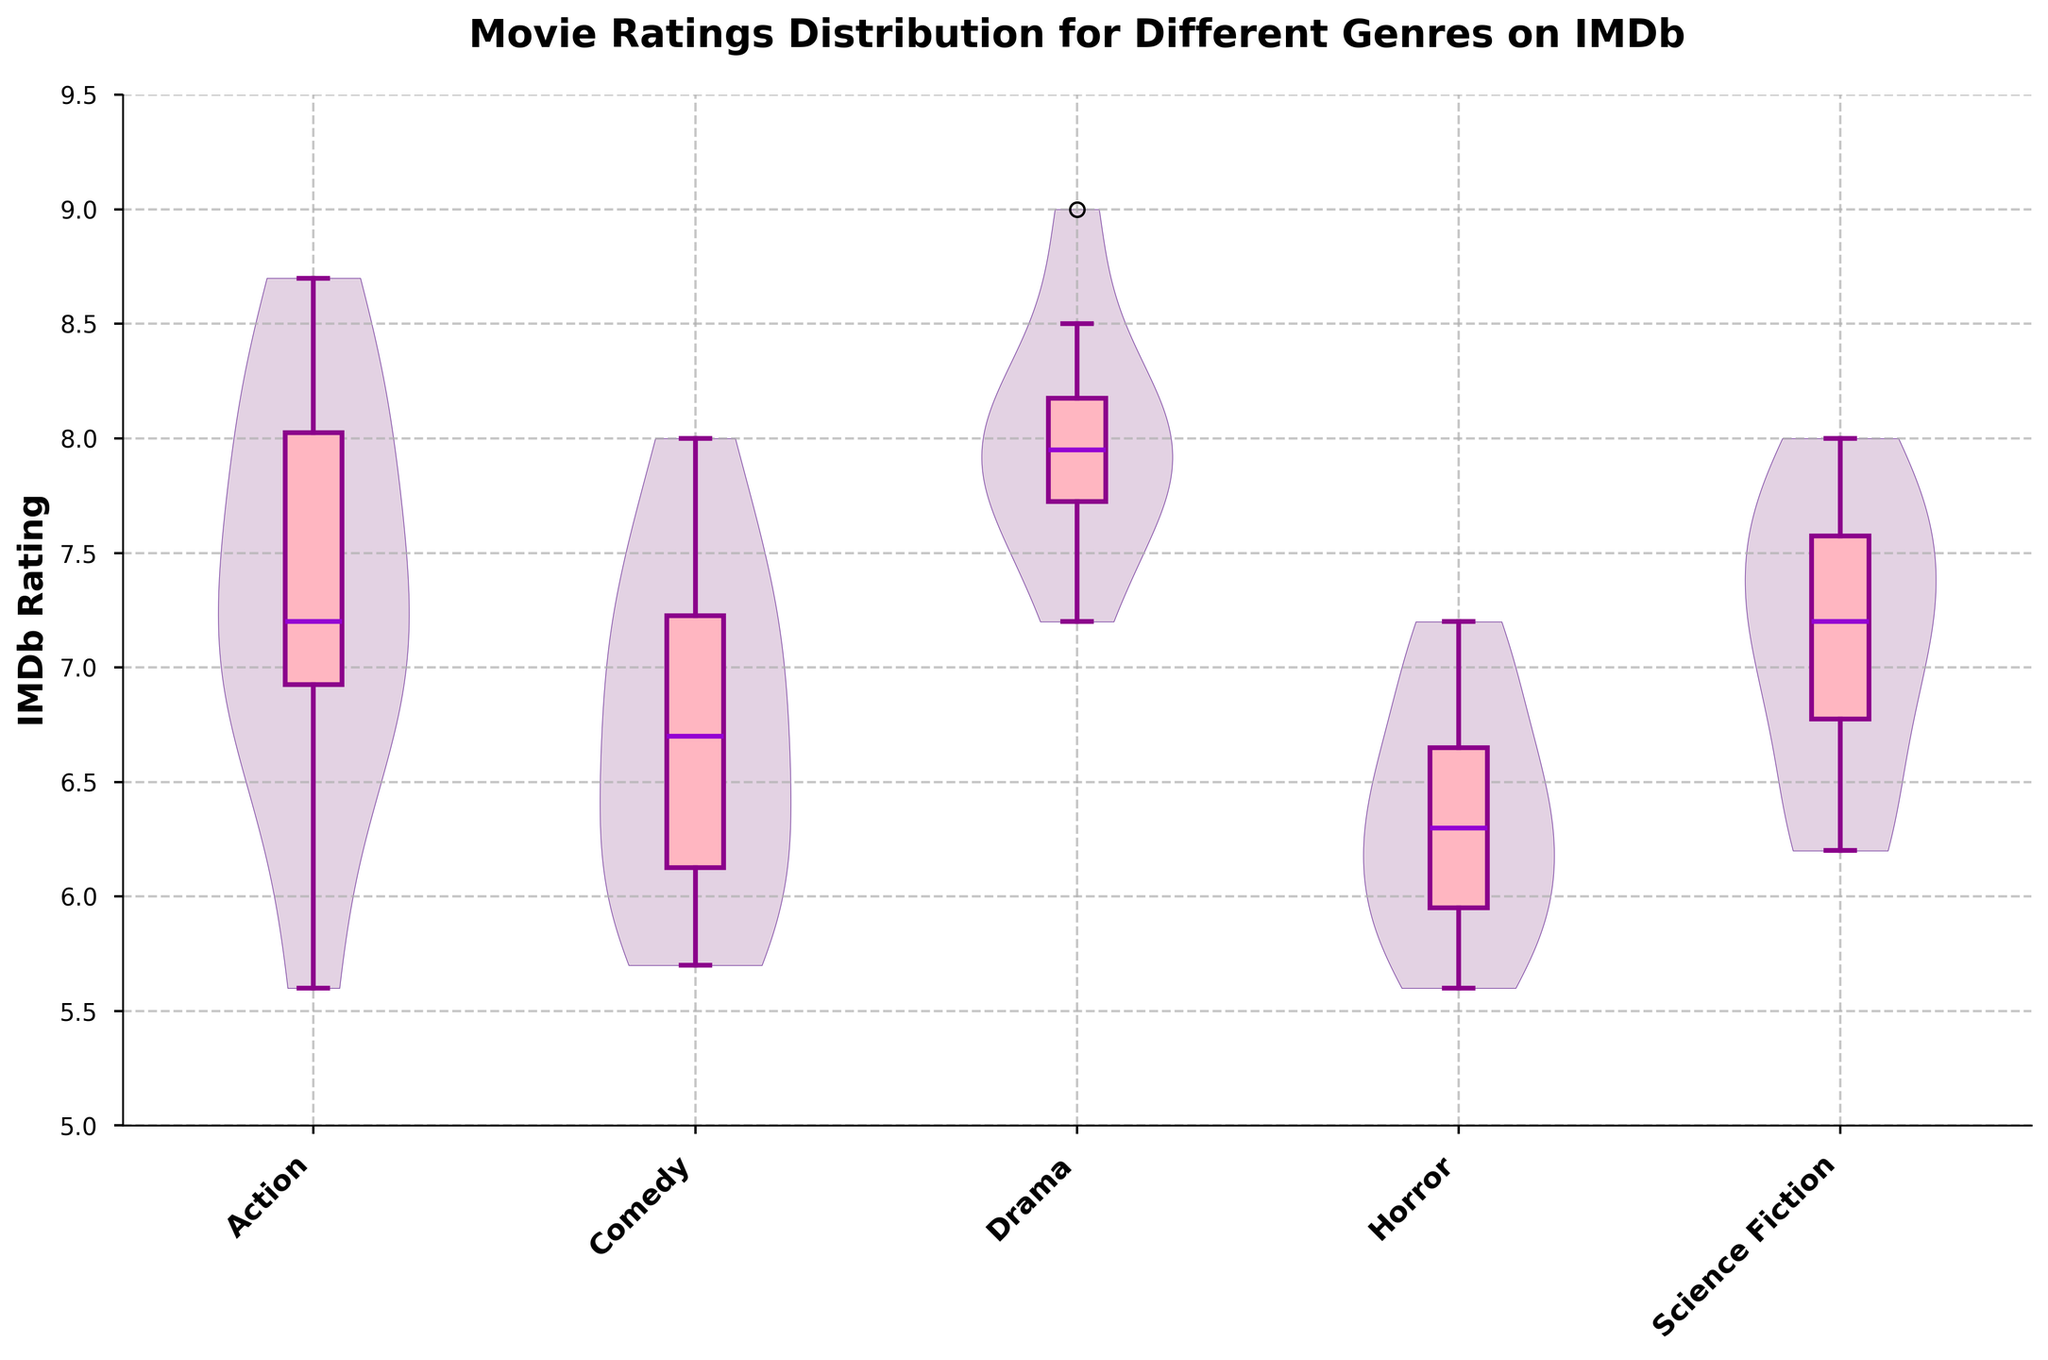What's the title of the violin chart with box plot overlay? The title of the violin chart with box plot overlay is found at the top of the figure and it states the main subject or focus of the plot. It reads "Movie Ratings Distribution for Different Genres on IMDb".
Answer: Movie Ratings Distribution for Different Genres on IMDb What are the ranges of IMDb ratings shown on the y-axis? The y-axis of the figure represents the IMDb ratings. The scale starts at 5 and goes up to 9.5. This range is indicated by the tick marks and numbers along the y-axis.
Answer: 5 to 9.5 Which genre has the highest median rating? The box plot overlay shows the median rating as a line inside each box. By comparing the medians for each genre, the drama genre has the highest median rating, which is slightly above 8.
Answer: Drama What is the median rating for the horror genre? To find the median rating, look for the line within the box plot for the horror genre. The line representing the median rating in horror is at 6.4.
Answer: 6.4 How does the distribution of ratings in the comedy genre compare to the action genre? By observing the widths and shapes of the violin plots, as well as the positions of the box plots, one can compare the distributions. The comedy genre has a wider spread, with more concentration around the median, whereas the action genre shows a somewhat narrower distribution.
Answer: Comedy is wider and more concentrated around the median, Action is narrower Which genre has the widest spread of ratings? The spread of ratings can be observed from the width of the violin plot. The comedy genre has the widest spread, indicating a broader variety of ratings.
Answer: Comedy What is the lowest rating observed for the action genre? The lowest rating in the action genre can be found at the bottom of the box plot's whisker for that genre, which dips down to approximately 5.6.
Answer: 5.6 Are the median ratings of the genres uniformly distributed? By examining the positions of the lines inside each genre's box plot, it is clear that the median ratings vary significantly across genres. They range from about 6.4 to slightly above 8, indicating a non-uniform distribution.
Answer: No By how much does the highest rating in the drama genre exceed the highest rating in the science fiction genre? The highest rating in the drama genre is 9, while the highest rating in the science fiction genre is 8. To find the difference, subtract 8 from 9, which is 1.
Answer: 1 Which genre shows the smallest interquartile range (IQR) and what does it imply? The interquartile range (IQR) is represented by the width of the box in the box plot for each genre. The horror genre has the smallest IQR, indicating less variability in its ratings.
Answer: Horror, less variability 